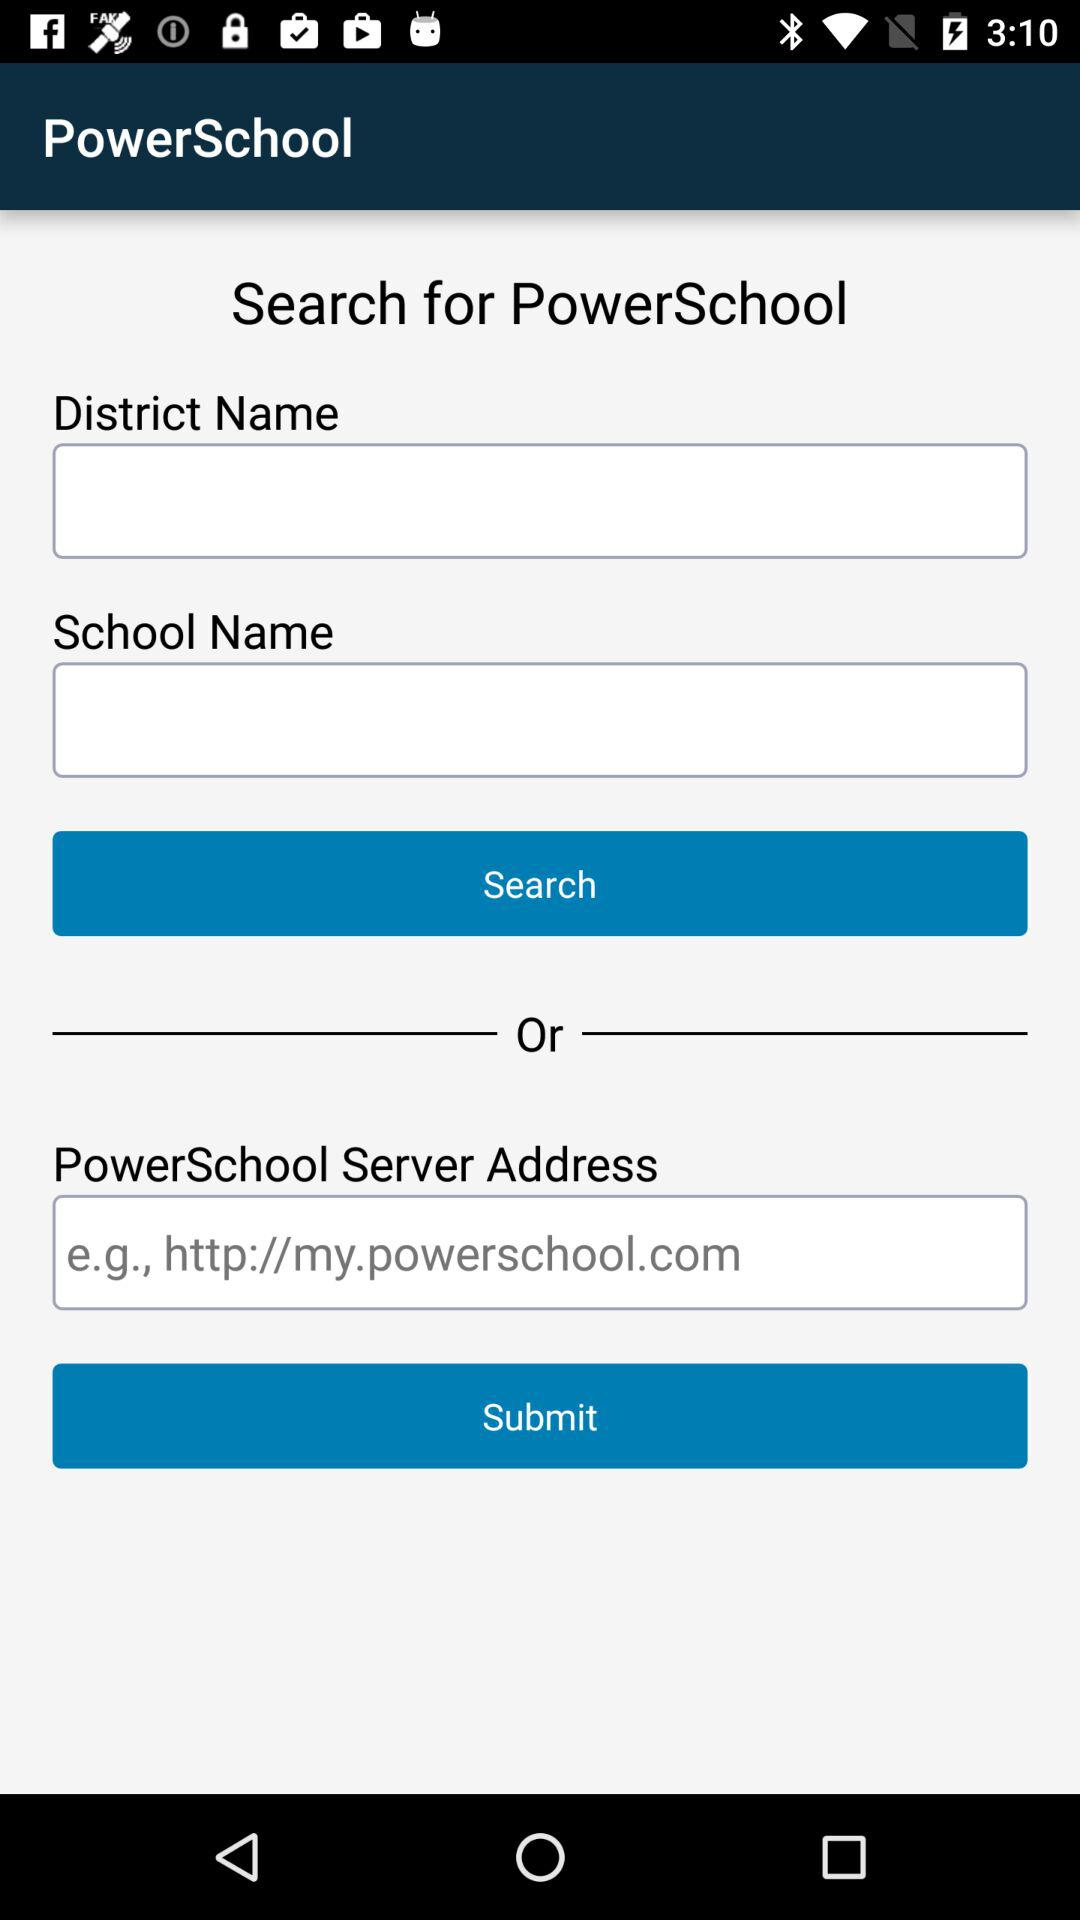What is the server address of "PowerSchool"? The server address is "http://my.powerschool.com". 